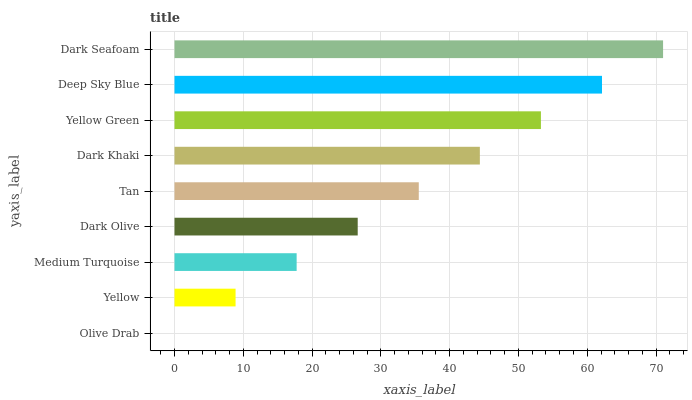Is Olive Drab the minimum?
Answer yes or no. Yes. Is Dark Seafoam the maximum?
Answer yes or no. Yes. Is Yellow the minimum?
Answer yes or no. No. Is Yellow the maximum?
Answer yes or no. No. Is Yellow greater than Olive Drab?
Answer yes or no. Yes. Is Olive Drab less than Yellow?
Answer yes or no. Yes. Is Olive Drab greater than Yellow?
Answer yes or no. No. Is Yellow less than Olive Drab?
Answer yes or no. No. Is Tan the high median?
Answer yes or no. Yes. Is Tan the low median?
Answer yes or no. Yes. Is Medium Turquoise the high median?
Answer yes or no. No. Is Yellow the low median?
Answer yes or no. No. 